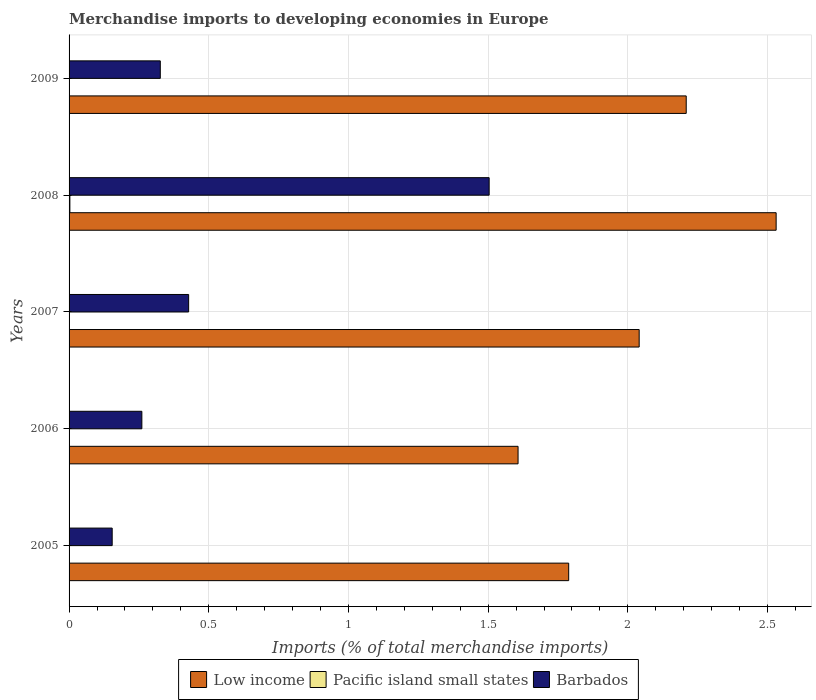How many different coloured bars are there?
Give a very brief answer. 3. How many groups of bars are there?
Your answer should be compact. 5. What is the label of the 2nd group of bars from the top?
Give a very brief answer. 2008. In how many cases, is the number of bars for a given year not equal to the number of legend labels?
Make the answer very short. 0. What is the percentage total merchandise imports in Low income in 2007?
Make the answer very short. 2.04. Across all years, what is the maximum percentage total merchandise imports in Barbados?
Provide a succinct answer. 1.5. Across all years, what is the minimum percentage total merchandise imports in Low income?
Your answer should be compact. 1.61. In which year was the percentage total merchandise imports in Low income minimum?
Your answer should be very brief. 2006. What is the total percentage total merchandise imports in Barbados in the graph?
Give a very brief answer. 2.67. What is the difference between the percentage total merchandise imports in Pacific island small states in 2006 and that in 2009?
Offer a terse response. -0. What is the difference between the percentage total merchandise imports in Low income in 2005 and the percentage total merchandise imports in Pacific island small states in 2008?
Give a very brief answer. 1.79. What is the average percentage total merchandise imports in Low income per year?
Make the answer very short. 2.04. In the year 2006, what is the difference between the percentage total merchandise imports in Low income and percentage total merchandise imports in Barbados?
Give a very brief answer. 1.35. In how many years, is the percentage total merchandise imports in Barbados greater than 1.9 %?
Provide a succinct answer. 0. What is the ratio of the percentage total merchandise imports in Barbados in 2005 to that in 2007?
Your answer should be compact. 0.36. Is the difference between the percentage total merchandise imports in Low income in 2007 and 2009 greater than the difference between the percentage total merchandise imports in Barbados in 2007 and 2009?
Provide a short and direct response. No. What is the difference between the highest and the second highest percentage total merchandise imports in Barbados?
Offer a terse response. 1.08. What is the difference between the highest and the lowest percentage total merchandise imports in Pacific island small states?
Your answer should be very brief. 0. In how many years, is the percentage total merchandise imports in Barbados greater than the average percentage total merchandise imports in Barbados taken over all years?
Offer a terse response. 1. Is the sum of the percentage total merchandise imports in Low income in 2008 and 2009 greater than the maximum percentage total merchandise imports in Pacific island small states across all years?
Your answer should be very brief. Yes. What does the 3rd bar from the bottom in 2007 represents?
Give a very brief answer. Barbados. Are all the bars in the graph horizontal?
Provide a succinct answer. Yes. How many years are there in the graph?
Your response must be concise. 5. Are the values on the major ticks of X-axis written in scientific E-notation?
Make the answer very short. No. Where does the legend appear in the graph?
Your answer should be very brief. Bottom center. What is the title of the graph?
Provide a succinct answer. Merchandise imports to developing economies in Europe. What is the label or title of the X-axis?
Offer a terse response. Imports (% of total merchandise imports). What is the Imports (% of total merchandise imports) in Low income in 2005?
Offer a very short reply. 1.79. What is the Imports (% of total merchandise imports) of Pacific island small states in 2005?
Offer a terse response. 0. What is the Imports (% of total merchandise imports) in Barbados in 2005?
Keep it short and to the point. 0.15. What is the Imports (% of total merchandise imports) of Low income in 2006?
Offer a very short reply. 1.61. What is the Imports (% of total merchandise imports) of Pacific island small states in 2006?
Your response must be concise. 9.530070980074692e-5. What is the Imports (% of total merchandise imports) in Barbados in 2006?
Ensure brevity in your answer.  0.26. What is the Imports (% of total merchandise imports) in Low income in 2007?
Ensure brevity in your answer.  2.04. What is the Imports (% of total merchandise imports) in Pacific island small states in 2007?
Give a very brief answer. 0. What is the Imports (% of total merchandise imports) in Barbados in 2007?
Offer a terse response. 0.43. What is the Imports (% of total merchandise imports) of Low income in 2008?
Keep it short and to the point. 2.53. What is the Imports (% of total merchandise imports) in Pacific island small states in 2008?
Your answer should be compact. 0. What is the Imports (% of total merchandise imports) in Barbados in 2008?
Provide a succinct answer. 1.5. What is the Imports (% of total merchandise imports) in Low income in 2009?
Ensure brevity in your answer.  2.21. What is the Imports (% of total merchandise imports) of Pacific island small states in 2009?
Provide a short and direct response. 0. What is the Imports (% of total merchandise imports) of Barbados in 2009?
Make the answer very short. 0.33. Across all years, what is the maximum Imports (% of total merchandise imports) in Low income?
Give a very brief answer. 2.53. Across all years, what is the maximum Imports (% of total merchandise imports) in Pacific island small states?
Ensure brevity in your answer.  0. Across all years, what is the maximum Imports (% of total merchandise imports) of Barbados?
Your answer should be compact. 1.5. Across all years, what is the minimum Imports (% of total merchandise imports) of Low income?
Ensure brevity in your answer.  1.61. Across all years, what is the minimum Imports (% of total merchandise imports) in Pacific island small states?
Ensure brevity in your answer.  9.530070980074692e-5. Across all years, what is the minimum Imports (% of total merchandise imports) of Barbados?
Provide a short and direct response. 0.15. What is the total Imports (% of total merchandise imports) of Low income in the graph?
Offer a terse response. 10.18. What is the total Imports (% of total merchandise imports) of Pacific island small states in the graph?
Keep it short and to the point. 0.01. What is the total Imports (% of total merchandise imports) in Barbados in the graph?
Give a very brief answer. 2.67. What is the difference between the Imports (% of total merchandise imports) in Low income in 2005 and that in 2006?
Give a very brief answer. 0.18. What is the difference between the Imports (% of total merchandise imports) in Barbados in 2005 and that in 2006?
Make the answer very short. -0.11. What is the difference between the Imports (% of total merchandise imports) in Low income in 2005 and that in 2007?
Keep it short and to the point. -0.25. What is the difference between the Imports (% of total merchandise imports) of Pacific island small states in 2005 and that in 2007?
Make the answer very short. 0. What is the difference between the Imports (% of total merchandise imports) in Barbados in 2005 and that in 2007?
Ensure brevity in your answer.  -0.27. What is the difference between the Imports (% of total merchandise imports) of Low income in 2005 and that in 2008?
Provide a short and direct response. -0.74. What is the difference between the Imports (% of total merchandise imports) in Pacific island small states in 2005 and that in 2008?
Your answer should be very brief. -0. What is the difference between the Imports (% of total merchandise imports) of Barbados in 2005 and that in 2008?
Your response must be concise. -1.35. What is the difference between the Imports (% of total merchandise imports) of Low income in 2005 and that in 2009?
Your answer should be very brief. -0.42. What is the difference between the Imports (% of total merchandise imports) in Pacific island small states in 2005 and that in 2009?
Offer a very short reply. 0. What is the difference between the Imports (% of total merchandise imports) in Barbados in 2005 and that in 2009?
Make the answer very short. -0.17. What is the difference between the Imports (% of total merchandise imports) in Low income in 2006 and that in 2007?
Provide a short and direct response. -0.43. What is the difference between the Imports (% of total merchandise imports) of Barbados in 2006 and that in 2007?
Offer a terse response. -0.17. What is the difference between the Imports (% of total merchandise imports) in Low income in 2006 and that in 2008?
Keep it short and to the point. -0.92. What is the difference between the Imports (% of total merchandise imports) in Pacific island small states in 2006 and that in 2008?
Your answer should be compact. -0. What is the difference between the Imports (% of total merchandise imports) in Barbados in 2006 and that in 2008?
Offer a very short reply. -1.24. What is the difference between the Imports (% of total merchandise imports) of Low income in 2006 and that in 2009?
Ensure brevity in your answer.  -0.6. What is the difference between the Imports (% of total merchandise imports) in Pacific island small states in 2006 and that in 2009?
Provide a short and direct response. -0. What is the difference between the Imports (% of total merchandise imports) of Barbados in 2006 and that in 2009?
Provide a succinct answer. -0.07. What is the difference between the Imports (% of total merchandise imports) in Low income in 2007 and that in 2008?
Give a very brief answer. -0.49. What is the difference between the Imports (% of total merchandise imports) in Pacific island small states in 2007 and that in 2008?
Provide a succinct answer. -0. What is the difference between the Imports (% of total merchandise imports) in Barbados in 2007 and that in 2008?
Offer a very short reply. -1.08. What is the difference between the Imports (% of total merchandise imports) of Low income in 2007 and that in 2009?
Your answer should be very brief. -0.17. What is the difference between the Imports (% of total merchandise imports) in Pacific island small states in 2007 and that in 2009?
Keep it short and to the point. -0. What is the difference between the Imports (% of total merchandise imports) in Barbados in 2007 and that in 2009?
Offer a very short reply. 0.1. What is the difference between the Imports (% of total merchandise imports) of Low income in 2008 and that in 2009?
Provide a short and direct response. 0.32. What is the difference between the Imports (% of total merchandise imports) of Pacific island small states in 2008 and that in 2009?
Provide a succinct answer. 0. What is the difference between the Imports (% of total merchandise imports) of Barbados in 2008 and that in 2009?
Your answer should be very brief. 1.18. What is the difference between the Imports (% of total merchandise imports) in Low income in 2005 and the Imports (% of total merchandise imports) in Pacific island small states in 2006?
Provide a succinct answer. 1.79. What is the difference between the Imports (% of total merchandise imports) of Low income in 2005 and the Imports (% of total merchandise imports) of Barbados in 2006?
Ensure brevity in your answer.  1.53. What is the difference between the Imports (% of total merchandise imports) in Pacific island small states in 2005 and the Imports (% of total merchandise imports) in Barbados in 2006?
Offer a terse response. -0.26. What is the difference between the Imports (% of total merchandise imports) in Low income in 2005 and the Imports (% of total merchandise imports) in Pacific island small states in 2007?
Ensure brevity in your answer.  1.79. What is the difference between the Imports (% of total merchandise imports) in Low income in 2005 and the Imports (% of total merchandise imports) in Barbados in 2007?
Provide a succinct answer. 1.36. What is the difference between the Imports (% of total merchandise imports) of Pacific island small states in 2005 and the Imports (% of total merchandise imports) of Barbados in 2007?
Give a very brief answer. -0.43. What is the difference between the Imports (% of total merchandise imports) of Low income in 2005 and the Imports (% of total merchandise imports) of Pacific island small states in 2008?
Keep it short and to the point. 1.79. What is the difference between the Imports (% of total merchandise imports) of Low income in 2005 and the Imports (% of total merchandise imports) of Barbados in 2008?
Your answer should be compact. 0.28. What is the difference between the Imports (% of total merchandise imports) in Pacific island small states in 2005 and the Imports (% of total merchandise imports) in Barbados in 2008?
Ensure brevity in your answer.  -1.5. What is the difference between the Imports (% of total merchandise imports) in Low income in 2005 and the Imports (% of total merchandise imports) in Pacific island small states in 2009?
Keep it short and to the point. 1.79. What is the difference between the Imports (% of total merchandise imports) of Low income in 2005 and the Imports (% of total merchandise imports) of Barbados in 2009?
Keep it short and to the point. 1.46. What is the difference between the Imports (% of total merchandise imports) in Pacific island small states in 2005 and the Imports (% of total merchandise imports) in Barbados in 2009?
Provide a short and direct response. -0.33. What is the difference between the Imports (% of total merchandise imports) in Low income in 2006 and the Imports (% of total merchandise imports) in Pacific island small states in 2007?
Offer a very short reply. 1.61. What is the difference between the Imports (% of total merchandise imports) in Low income in 2006 and the Imports (% of total merchandise imports) in Barbados in 2007?
Give a very brief answer. 1.18. What is the difference between the Imports (% of total merchandise imports) in Pacific island small states in 2006 and the Imports (% of total merchandise imports) in Barbados in 2007?
Offer a very short reply. -0.43. What is the difference between the Imports (% of total merchandise imports) of Low income in 2006 and the Imports (% of total merchandise imports) of Pacific island small states in 2008?
Provide a short and direct response. 1.6. What is the difference between the Imports (% of total merchandise imports) of Low income in 2006 and the Imports (% of total merchandise imports) of Barbados in 2008?
Offer a terse response. 0.1. What is the difference between the Imports (% of total merchandise imports) in Pacific island small states in 2006 and the Imports (% of total merchandise imports) in Barbados in 2008?
Offer a terse response. -1.5. What is the difference between the Imports (% of total merchandise imports) in Low income in 2006 and the Imports (% of total merchandise imports) in Pacific island small states in 2009?
Provide a short and direct response. 1.61. What is the difference between the Imports (% of total merchandise imports) in Low income in 2006 and the Imports (% of total merchandise imports) in Barbados in 2009?
Provide a succinct answer. 1.28. What is the difference between the Imports (% of total merchandise imports) of Pacific island small states in 2006 and the Imports (% of total merchandise imports) of Barbados in 2009?
Keep it short and to the point. -0.33. What is the difference between the Imports (% of total merchandise imports) of Low income in 2007 and the Imports (% of total merchandise imports) of Pacific island small states in 2008?
Make the answer very short. 2.04. What is the difference between the Imports (% of total merchandise imports) in Low income in 2007 and the Imports (% of total merchandise imports) in Barbados in 2008?
Provide a succinct answer. 0.54. What is the difference between the Imports (% of total merchandise imports) of Pacific island small states in 2007 and the Imports (% of total merchandise imports) of Barbados in 2008?
Ensure brevity in your answer.  -1.5. What is the difference between the Imports (% of total merchandise imports) in Low income in 2007 and the Imports (% of total merchandise imports) in Pacific island small states in 2009?
Your answer should be compact. 2.04. What is the difference between the Imports (% of total merchandise imports) of Low income in 2007 and the Imports (% of total merchandise imports) of Barbados in 2009?
Keep it short and to the point. 1.71. What is the difference between the Imports (% of total merchandise imports) of Pacific island small states in 2007 and the Imports (% of total merchandise imports) of Barbados in 2009?
Your response must be concise. -0.33. What is the difference between the Imports (% of total merchandise imports) in Low income in 2008 and the Imports (% of total merchandise imports) in Pacific island small states in 2009?
Offer a terse response. 2.53. What is the difference between the Imports (% of total merchandise imports) of Low income in 2008 and the Imports (% of total merchandise imports) of Barbados in 2009?
Give a very brief answer. 2.2. What is the difference between the Imports (% of total merchandise imports) in Pacific island small states in 2008 and the Imports (% of total merchandise imports) in Barbados in 2009?
Ensure brevity in your answer.  -0.32. What is the average Imports (% of total merchandise imports) of Low income per year?
Your response must be concise. 2.04. What is the average Imports (% of total merchandise imports) in Pacific island small states per year?
Your answer should be very brief. 0. What is the average Imports (% of total merchandise imports) in Barbados per year?
Ensure brevity in your answer.  0.53. In the year 2005, what is the difference between the Imports (% of total merchandise imports) of Low income and Imports (% of total merchandise imports) of Pacific island small states?
Your answer should be very brief. 1.79. In the year 2005, what is the difference between the Imports (% of total merchandise imports) in Low income and Imports (% of total merchandise imports) in Barbados?
Keep it short and to the point. 1.63. In the year 2005, what is the difference between the Imports (% of total merchandise imports) of Pacific island small states and Imports (% of total merchandise imports) of Barbados?
Provide a succinct answer. -0.15. In the year 2006, what is the difference between the Imports (% of total merchandise imports) of Low income and Imports (% of total merchandise imports) of Pacific island small states?
Your answer should be very brief. 1.61. In the year 2006, what is the difference between the Imports (% of total merchandise imports) in Low income and Imports (% of total merchandise imports) in Barbados?
Offer a very short reply. 1.35. In the year 2006, what is the difference between the Imports (% of total merchandise imports) in Pacific island small states and Imports (% of total merchandise imports) in Barbados?
Provide a short and direct response. -0.26. In the year 2007, what is the difference between the Imports (% of total merchandise imports) of Low income and Imports (% of total merchandise imports) of Pacific island small states?
Your answer should be compact. 2.04. In the year 2007, what is the difference between the Imports (% of total merchandise imports) in Low income and Imports (% of total merchandise imports) in Barbados?
Your answer should be compact. 1.61. In the year 2007, what is the difference between the Imports (% of total merchandise imports) in Pacific island small states and Imports (% of total merchandise imports) in Barbados?
Provide a succinct answer. -0.43. In the year 2008, what is the difference between the Imports (% of total merchandise imports) of Low income and Imports (% of total merchandise imports) of Pacific island small states?
Provide a short and direct response. 2.53. In the year 2008, what is the difference between the Imports (% of total merchandise imports) of Low income and Imports (% of total merchandise imports) of Barbados?
Offer a very short reply. 1.03. In the year 2008, what is the difference between the Imports (% of total merchandise imports) of Pacific island small states and Imports (% of total merchandise imports) of Barbados?
Keep it short and to the point. -1.5. In the year 2009, what is the difference between the Imports (% of total merchandise imports) in Low income and Imports (% of total merchandise imports) in Pacific island small states?
Your answer should be very brief. 2.21. In the year 2009, what is the difference between the Imports (% of total merchandise imports) of Low income and Imports (% of total merchandise imports) of Barbados?
Give a very brief answer. 1.88. In the year 2009, what is the difference between the Imports (% of total merchandise imports) of Pacific island small states and Imports (% of total merchandise imports) of Barbados?
Provide a succinct answer. -0.33. What is the ratio of the Imports (% of total merchandise imports) of Low income in 2005 to that in 2006?
Ensure brevity in your answer.  1.11. What is the ratio of the Imports (% of total merchandise imports) in Pacific island small states in 2005 to that in 2006?
Your answer should be compact. 11.85. What is the ratio of the Imports (% of total merchandise imports) of Barbados in 2005 to that in 2006?
Your response must be concise. 0.59. What is the ratio of the Imports (% of total merchandise imports) of Low income in 2005 to that in 2007?
Make the answer very short. 0.88. What is the ratio of the Imports (% of total merchandise imports) of Pacific island small states in 2005 to that in 2007?
Make the answer very short. 10.93. What is the ratio of the Imports (% of total merchandise imports) of Barbados in 2005 to that in 2007?
Your answer should be very brief. 0.36. What is the ratio of the Imports (% of total merchandise imports) of Low income in 2005 to that in 2008?
Offer a very short reply. 0.71. What is the ratio of the Imports (% of total merchandise imports) in Pacific island small states in 2005 to that in 2008?
Your response must be concise. 0.39. What is the ratio of the Imports (% of total merchandise imports) of Barbados in 2005 to that in 2008?
Offer a very short reply. 0.1. What is the ratio of the Imports (% of total merchandise imports) of Low income in 2005 to that in 2009?
Your response must be concise. 0.81. What is the ratio of the Imports (% of total merchandise imports) of Pacific island small states in 2005 to that in 2009?
Your answer should be compact. 1.15. What is the ratio of the Imports (% of total merchandise imports) in Barbados in 2005 to that in 2009?
Give a very brief answer. 0.47. What is the ratio of the Imports (% of total merchandise imports) of Low income in 2006 to that in 2007?
Your answer should be very brief. 0.79. What is the ratio of the Imports (% of total merchandise imports) of Pacific island small states in 2006 to that in 2007?
Provide a short and direct response. 0.92. What is the ratio of the Imports (% of total merchandise imports) in Barbados in 2006 to that in 2007?
Provide a short and direct response. 0.61. What is the ratio of the Imports (% of total merchandise imports) in Low income in 2006 to that in 2008?
Provide a succinct answer. 0.64. What is the ratio of the Imports (% of total merchandise imports) in Pacific island small states in 2006 to that in 2008?
Ensure brevity in your answer.  0.03. What is the ratio of the Imports (% of total merchandise imports) in Barbados in 2006 to that in 2008?
Offer a very short reply. 0.17. What is the ratio of the Imports (% of total merchandise imports) in Low income in 2006 to that in 2009?
Provide a succinct answer. 0.73. What is the ratio of the Imports (% of total merchandise imports) of Pacific island small states in 2006 to that in 2009?
Your response must be concise. 0.1. What is the ratio of the Imports (% of total merchandise imports) in Barbados in 2006 to that in 2009?
Ensure brevity in your answer.  0.8. What is the ratio of the Imports (% of total merchandise imports) of Low income in 2007 to that in 2008?
Your answer should be very brief. 0.81. What is the ratio of the Imports (% of total merchandise imports) of Pacific island small states in 2007 to that in 2008?
Your answer should be very brief. 0.04. What is the ratio of the Imports (% of total merchandise imports) of Barbados in 2007 to that in 2008?
Ensure brevity in your answer.  0.28. What is the ratio of the Imports (% of total merchandise imports) in Low income in 2007 to that in 2009?
Offer a terse response. 0.92. What is the ratio of the Imports (% of total merchandise imports) in Pacific island small states in 2007 to that in 2009?
Keep it short and to the point. 0.11. What is the ratio of the Imports (% of total merchandise imports) in Barbados in 2007 to that in 2009?
Your answer should be very brief. 1.31. What is the ratio of the Imports (% of total merchandise imports) in Low income in 2008 to that in 2009?
Make the answer very short. 1.15. What is the ratio of the Imports (% of total merchandise imports) of Pacific island small states in 2008 to that in 2009?
Keep it short and to the point. 2.93. What is the ratio of the Imports (% of total merchandise imports) in Barbados in 2008 to that in 2009?
Keep it short and to the point. 4.6. What is the difference between the highest and the second highest Imports (% of total merchandise imports) in Low income?
Provide a short and direct response. 0.32. What is the difference between the highest and the second highest Imports (% of total merchandise imports) in Pacific island small states?
Provide a short and direct response. 0. What is the difference between the highest and the second highest Imports (% of total merchandise imports) in Barbados?
Provide a short and direct response. 1.08. What is the difference between the highest and the lowest Imports (% of total merchandise imports) of Low income?
Provide a succinct answer. 0.92. What is the difference between the highest and the lowest Imports (% of total merchandise imports) in Pacific island small states?
Give a very brief answer. 0. What is the difference between the highest and the lowest Imports (% of total merchandise imports) in Barbados?
Keep it short and to the point. 1.35. 